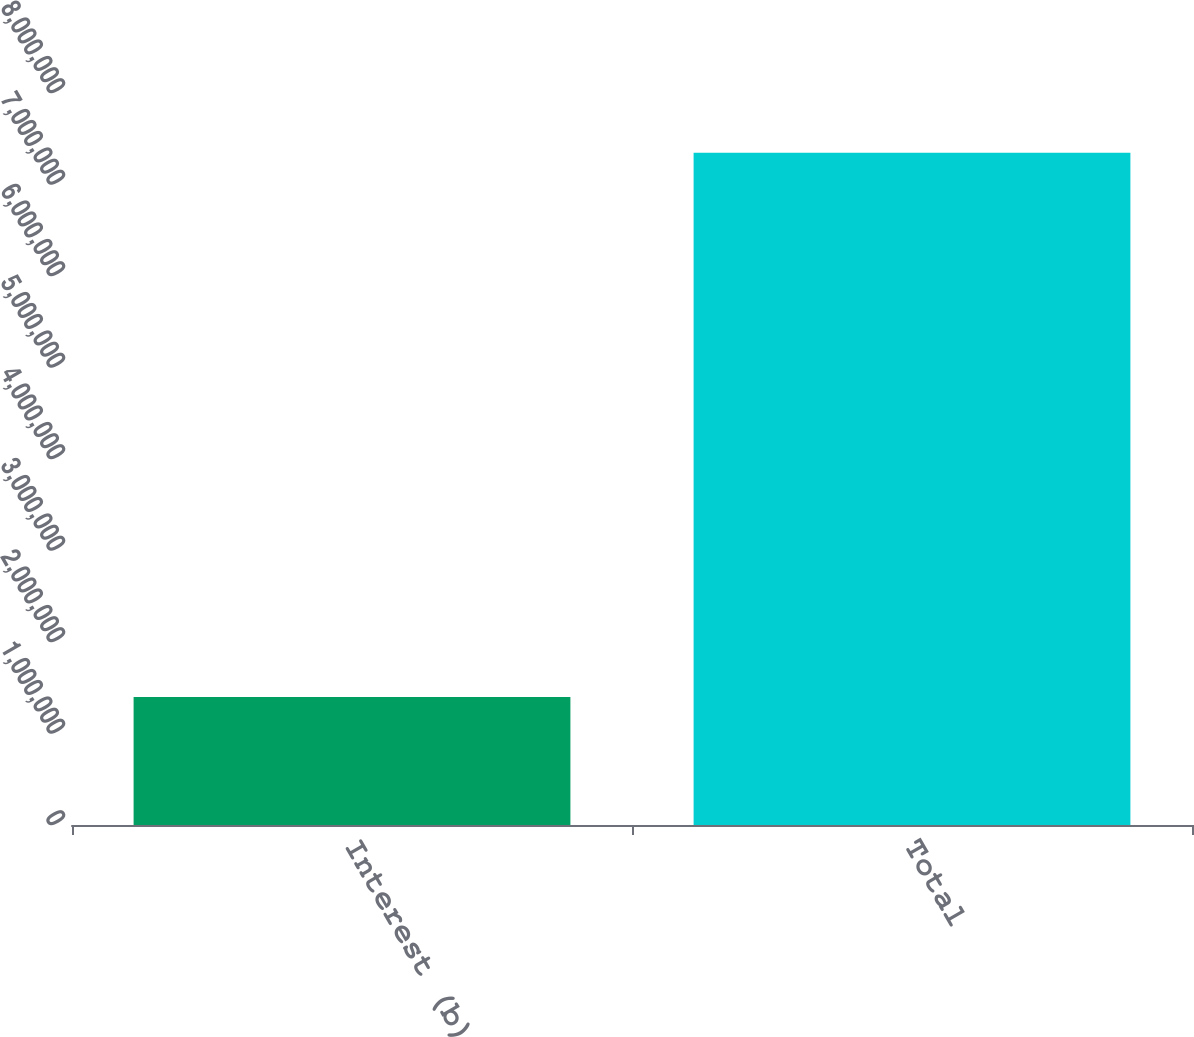<chart> <loc_0><loc_0><loc_500><loc_500><bar_chart><fcel>Interest (b)<fcel>Total<nl><fcel>1.39854e+06<fcel>7.34836e+06<nl></chart> 